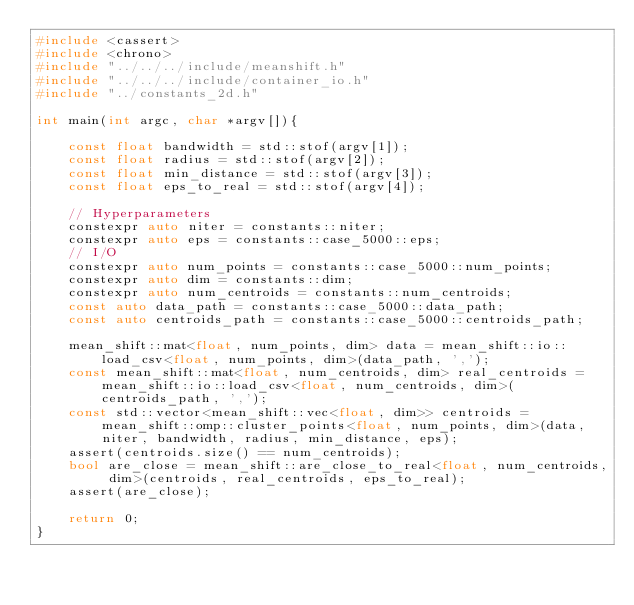<code> <loc_0><loc_0><loc_500><loc_500><_C++_>#include <cassert>
#include <chrono>
#include "../../../include/meanshift.h"
#include "../../../include/container_io.h"
#include "../constants_2d.h"

int main(int argc, char *argv[]){

    const float bandwidth = std::stof(argv[1]);
    const float radius = std::stof(argv[2]);
    const float min_distance = std::stof(argv[3]);
    const float eps_to_real = std::stof(argv[4]);

    // Hyperparameters
    constexpr auto niter = constants::niter;
    constexpr auto eps = constants::case_5000::eps;
    // I/O
    constexpr auto num_points = constants::case_5000::num_points;
    constexpr auto dim = constants::dim;
    constexpr auto num_centroids = constants::num_centroids;
    const auto data_path = constants::case_5000::data_path;
    const auto centroids_path = constants::case_5000::centroids_path;

    mean_shift::mat<float, num_points, dim> data = mean_shift::io::load_csv<float, num_points, dim>(data_path, ',');
    const mean_shift::mat<float, num_centroids, dim> real_centroids = mean_shift::io::load_csv<float, num_centroids, dim>(centroids_path, ',');
    const std::vector<mean_shift::vec<float, dim>> centroids = mean_shift::omp::cluster_points<float, num_points, dim>(data, niter, bandwidth, radius, min_distance, eps);    
    assert(centroids.size() == num_centroids);
    bool are_close = mean_shift::are_close_to_real<float, num_centroids, dim>(centroids, real_centroids, eps_to_real);
    assert(are_close);

    return 0;
}</code> 